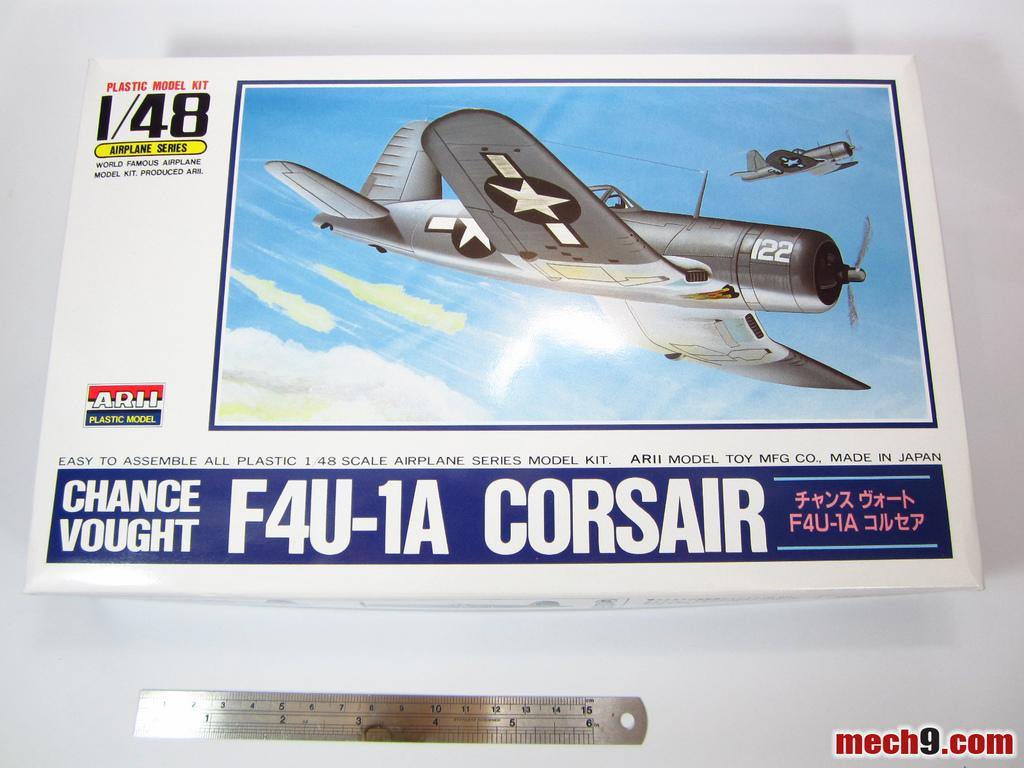<image>
Present a compact description of the photo's key features. A 1/48 scale Corsair model is on a table by a ruler. 